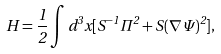Convert formula to latex. <formula><loc_0><loc_0><loc_500><loc_500>H = \frac { 1 } { 2 } \int d ^ { 3 } x [ S ^ { - 1 } \Pi ^ { 2 } + S ( \nabla \Psi ) ^ { 2 } ] ,</formula> 